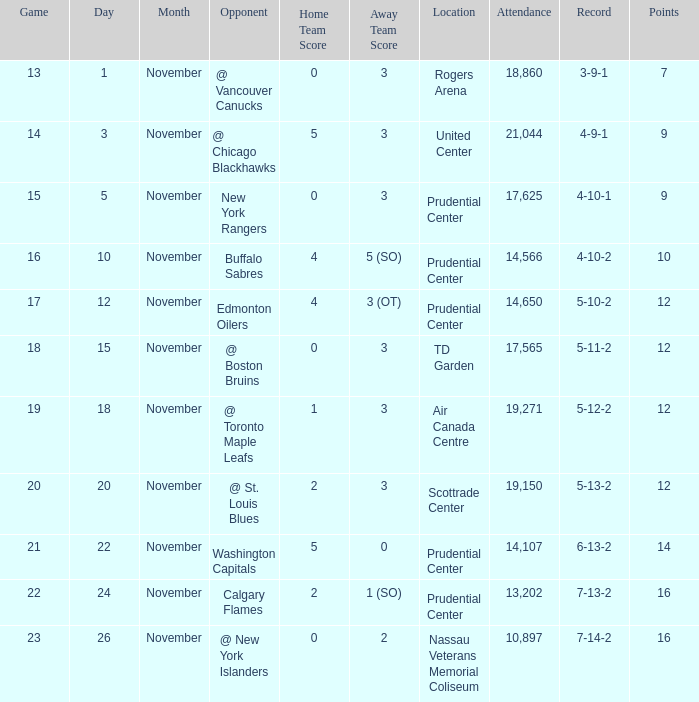Could you help me parse every detail presented in this table? {'header': ['Game', 'Day', 'Month', 'Opponent', 'Home Team Score', 'Away Team Score', 'Location', 'Attendance', 'Record', 'Points'], 'rows': [['13', '1', 'November', '@ Vancouver Canucks', '0', '3', 'Rogers Arena', '18,860', '3-9-1', '7'], ['14', '3', 'November', '@ Chicago Blackhawks', '5', '3', 'United Center', '21,044', '4-9-1', '9'], ['15', '5', 'November', 'New York Rangers', '0', '3', 'Prudential Center', '17,625', '4-10-1', '9'], ['16', '10', 'November', 'Buffalo Sabres', '4', '5 (SO)', 'Prudential Center', '14,566', '4-10-2', '10'], ['17', '12', 'November', 'Edmonton Oilers', '4', '3 (OT)', 'Prudential Center', '14,650', '5-10-2', '12'], ['18', '15', 'November', '@ Boston Bruins', '0', '3', 'TD Garden', '17,565', '5-11-2', '12'], ['19', '18', 'November', '@ Toronto Maple Leafs', '1', '3', 'Air Canada Centre', '19,271', '5-12-2', '12'], ['20', '20', 'November', '@ St. Louis Blues', '2', '3', 'Scottrade Center', '19,150', '5-13-2', '12'], ['21', '22', 'November', 'Washington Capitals', '5', '0', 'Prudential Center', '14,107', '6-13-2', '14'], ['22', '24', 'November', 'Calgary Flames', '2', '1 (SO)', 'Prudential Center', '13,202', '7-13-2', '16'], ['23', '26', 'November', '@ New York Islanders', '0', '2', 'Nassau Veterans Memorial Coliseum', '10,897', '7-14-2', '16']]} What is the record that had a score of 5-3? 4-9-1. 